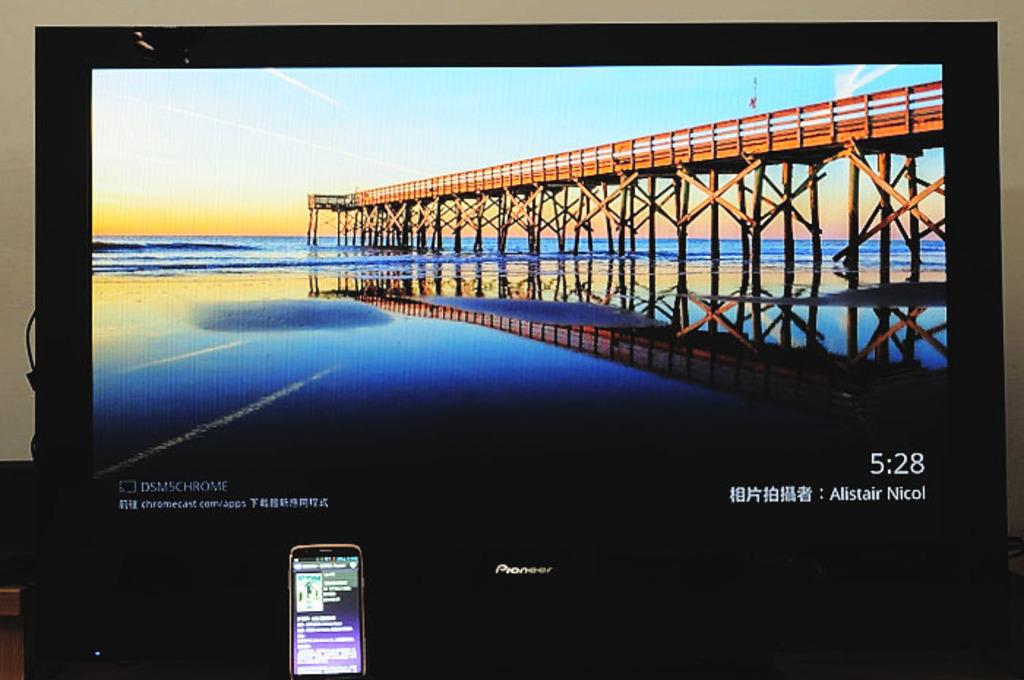What time is it?
Your answer should be very brief. 5:28. What is the name written under the timestamp?
Offer a very short reply. Alistair nicol. 